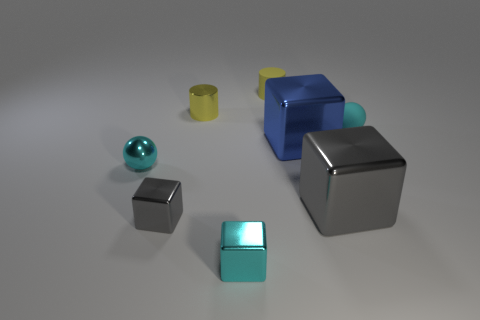What number of other things are there of the same size as the metallic sphere?
Make the answer very short. 5. Is the small gray cube made of the same material as the big blue cube?
Ensure brevity in your answer.  Yes. There is a metal cube that is in front of the tiny gray cube that is on the left side of the large blue metal object; what is its color?
Offer a very short reply. Cyan. There is another object that is the same shape as the cyan rubber object; what is its size?
Offer a very short reply. Small. Does the matte sphere have the same color as the small metal cylinder?
Ensure brevity in your answer.  No. How many small cyan objects are to the right of the cyan shiny object that is behind the gray metallic block that is left of the small cyan block?
Your answer should be very brief. 2. Are there more tiny matte things than metal spheres?
Your response must be concise. Yes. What number of gray cylinders are there?
Keep it short and to the point. 0. There is a small cyan metal thing that is right of the cylinder that is on the left side of the matte object to the left of the cyan matte object; what is its shape?
Ensure brevity in your answer.  Cube. Is the number of small cyan blocks on the right side of the tiny cyan matte ball less than the number of tiny cylinders that are in front of the yellow rubber cylinder?
Provide a short and direct response. Yes. 